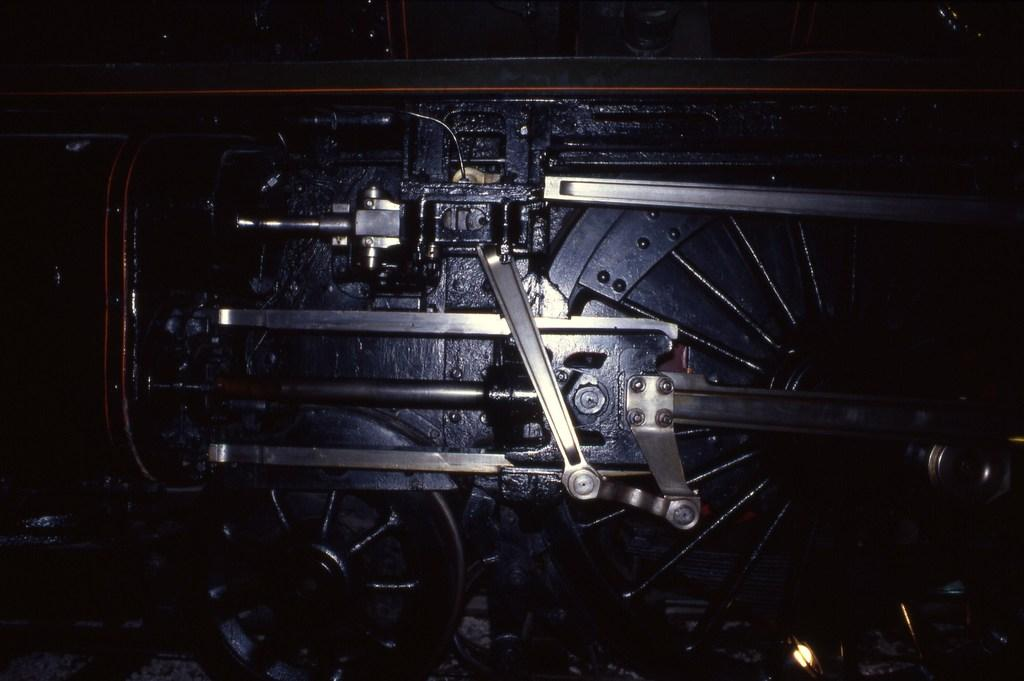What is the main object in the image? There is a machine in the image. What are some features of the machine? The machine has wheels, rods, and bolts. What can be inferred about the machine's function? The machine appears to be a part, suggesting it is a component of a larger system. Can you see a rabbit gripping the stem of a flower in the image? There is no rabbit or flower stem present in the image; it features a machine with wheels, rods, and bolts. 